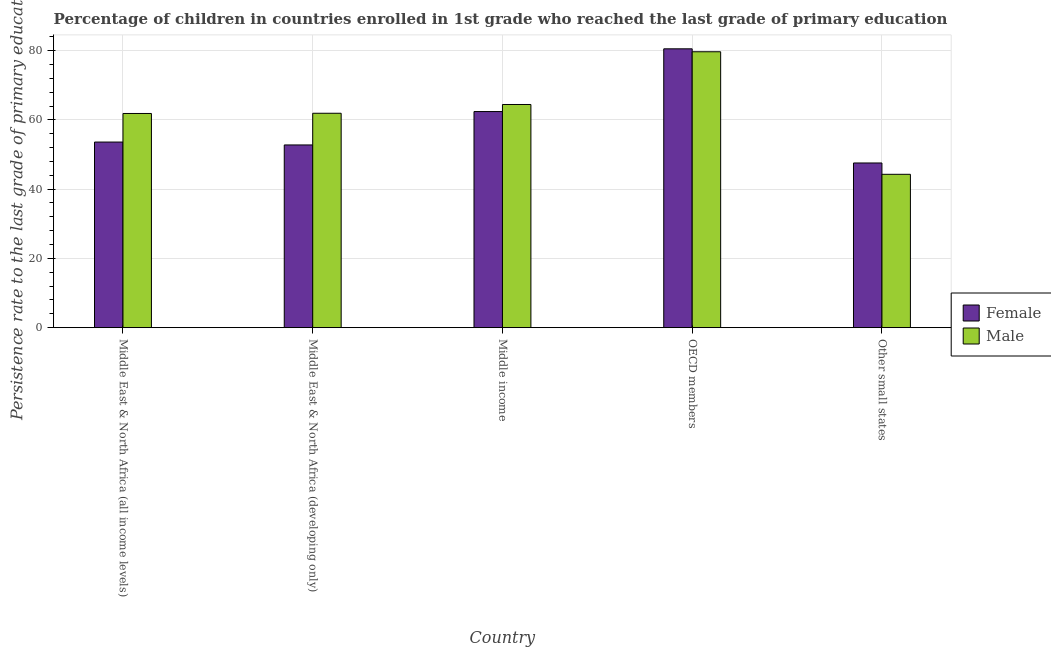How many different coloured bars are there?
Provide a succinct answer. 2. Are the number of bars per tick equal to the number of legend labels?
Ensure brevity in your answer.  Yes. How many bars are there on the 3rd tick from the left?
Ensure brevity in your answer.  2. What is the label of the 2nd group of bars from the left?
Ensure brevity in your answer.  Middle East & North Africa (developing only). What is the persistence rate of male students in OECD members?
Keep it short and to the point. 79.66. Across all countries, what is the maximum persistence rate of male students?
Your response must be concise. 79.66. Across all countries, what is the minimum persistence rate of female students?
Your response must be concise. 47.55. In which country was the persistence rate of male students maximum?
Your answer should be very brief. OECD members. In which country was the persistence rate of male students minimum?
Provide a succinct answer. Other small states. What is the total persistence rate of female students in the graph?
Offer a terse response. 296.81. What is the difference between the persistence rate of male students in Middle East & North Africa (all income levels) and that in OECD members?
Ensure brevity in your answer.  -17.82. What is the difference between the persistence rate of female students in Middle East & North Africa (developing only) and the persistence rate of male students in Other small states?
Provide a succinct answer. 8.48. What is the average persistence rate of male students per country?
Offer a very short reply. 62.43. What is the difference between the persistence rate of male students and persistence rate of female students in Middle income?
Provide a short and direct response. 2.04. What is the ratio of the persistence rate of male students in Middle East & North Africa (developing only) to that in OECD members?
Make the answer very short. 0.78. What is the difference between the highest and the second highest persistence rate of female students?
Offer a terse response. 18.11. What is the difference between the highest and the lowest persistence rate of female students?
Provide a succinct answer. 32.96. In how many countries, is the persistence rate of male students greater than the average persistence rate of male students taken over all countries?
Offer a very short reply. 2. Is the sum of the persistence rate of male students in Middle East & North Africa (developing only) and Middle income greater than the maximum persistence rate of female students across all countries?
Your answer should be very brief. Yes. What does the 2nd bar from the left in Other small states represents?
Provide a short and direct response. Male. What does the 2nd bar from the right in Middle East & North Africa (developing only) represents?
Keep it short and to the point. Female. Are all the bars in the graph horizontal?
Offer a very short reply. No. How many countries are there in the graph?
Ensure brevity in your answer.  5. Does the graph contain grids?
Give a very brief answer. Yes. Where does the legend appear in the graph?
Offer a very short reply. Center right. How many legend labels are there?
Your response must be concise. 2. What is the title of the graph?
Give a very brief answer. Percentage of children in countries enrolled in 1st grade who reached the last grade of primary education. What is the label or title of the Y-axis?
Offer a very short reply. Persistence rate to the last grade of primary education (%). What is the Persistence rate to the last grade of primary education (%) of Female in Middle East & North Africa (all income levels)?
Make the answer very short. 53.59. What is the Persistence rate to the last grade of primary education (%) of Male in Middle East & North Africa (all income levels)?
Make the answer very short. 61.84. What is the Persistence rate to the last grade of primary education (%) of Female in Middle East & North Africa (developing only)?
Make the answer very short. 52.76. What is the Persistence rate to the last grade of primary education (%) in Male in Middle East & North Africa (developing only)?
Offer a very short reply. 61.91. What is the Persistence rate to the last grade of primary education (%) in Female in Middle income?
Keep it short and to the point. 62.4. What is the Persistence rate to the last grade of primary education (%) of Male in Middle income?
Offer a very short reply. 64.44. What is the Persistence rate to the last grade of primary education (%) in Female in OECD members?
Ensure brevity in your answer.  80.51. What is the Persistence rate to the last grade of primary education (%) in Male in OECD members?
Offer a terse response. 79.66. What is the Persistence rate to the last grade of primary education (%) of Female in Other small states?
Provide a succinct answer. 47.55. What is the Persistence rate to the last grade of primary education (%) of Male in Other small states?
Offer a terse response. 44.28. Across all countries, what is the maximum Persistence rate to the last grade of primary education (%) in Female?
Your response must be concise. 80.51. Across all countries, what is the maximum Persistence rate to the last grade of primary education (%) of Male?
Give a very brief answer. 79.66. Across all countries, what is the minimum Persistence rate to the last grade of primary education (%) in Female?
Make the answer very short. 47.55. Across all countries, what is the minimum Persistence rate to the last grade of primary education (%) in Male?
Offer a very short reply. 44.28. What is the total Persistence rate to the last grade of primary education (%) in Female in the graph?
Your answer should be compact. 296.81. What is the total Persistence rate to the last grade of primary education (%) in Male in the graph?
Your answer should be very brief. 312.13. What is the difference between the Persistence rate to the last grade of primary education (%) in Female in Middle East & North Africa (all income levels) and that in Middle East & North Africa (developing only)?
Your response must be concise. 0.84. What is the difference between the Persistence rate to the last grade of primary education (%) of Male in Middle East & North Africa (all income levels) and that in Middle East & North Africa (developing only)?
Ensure brevity in your answer.  -0.06. What is the difference between the Persistence rate to the last grade of primary education (%) of Female in Middle East & North Africa (all income levels) and that in Middle income?
Your answer should be compact. -8.8. What is the difference between the Persistence rate to the last grade of primary education (%) in Male in Middle East & North Africa (all income levels) and that in Middle income?
Provide a short and direct response. -2.59. What is the difference between the Persistence rate to the last grade of primary education (%) of Female in Middle East & North Africa (all income levels) and that in OECD members?
Offer a terse response. -26.92. What is the difference between the Persistence rate to the last grade of primary education (%) of Male in Middle East & North Africa (all income levels) and that in OECD members?
Offer a very short reply. -17.82. What is the difference between the Persistence rate to the last grade of primary education (%) in Female in Middle East & North Africa (all income levels) and that in Other small states?
Offer a terse response. 6.04. What is the difference between the Persistence rate to the last grade of primary education (%) of Male in Middle East & North Africa (all income levels) and that in Other small states?
Offer a very short reply. 17.56. What is the difference between the Persistence rate to the last grade of primary education (%) of Female in Middle East & North Africa (developing only) and that in Middle income?
Ensure brevity in your answer.  -9.64. What is the difference between the Persistence rate to the last grade of primary education (%) in Male in Middle East & North Africa (developing only) and that in Middle income?
Offer a very short reply. -2.53. What is the difference between the Persistence rate to the last grade of primary education (%) of Female in Middle East & North Africa (developing only) and that in OECD members?
Your answer should be compact. -27.76. What is the difference between the Persistence rate to the last grade of primary education (%) of Male in Middle East & North Africa (developing only) and that in OECD members?
Your answer should be very brief. -17.76. What is the difference between the Persistence rate to the last grade of primary education (%) in Female in Middle East & North Africa (developing only) and that in Other small states?
Your answer should be very brief. 5.2. What is the difference between the Persistence rate to the last grade of primary education (%) of Male in Middle East & North Africa (developing only) and that in Other small states?
Give a very brief answer. 17.63. What is the difference between the Persistence rate to the last grade of primary education (%) in Female in Middle income and that in OECD members?
Keep it short and to the point. -18.11. What is the difference between the Persistence rate to the last grade of primary education (%) in Male in Middle income and that in OECD members?
Offer a terse response. -15.23. What is the difference between the Persistence rate to the last grade of primary education (%) of Female in Middle income and that in Other small states?
Provide a short and direct response. 14.85. What is the difference between the Persistence rate to the last grade of primary education (%) of Male in Middle income and that in Other small states?
Offer a very short reply. 20.16. What is the difference between the Persistence rate to the last grade of primary education (%) of Female in OECD members and that in Other small states?
Your answer should be compact. 32.96. What is the difference between the Persistence rate to the last grade of primary education (%) in Male in OECD members and that in Other small states?
Provide a short and direct response. 35.38. What is the difference between the Persistence rate to the last grade of primary education (%) of Female in Middle East & North Africa (all income levels) and the Persistence rate to the last grade of primary education (%) of Male in Middle East & North Africa (developing only)?
Give a very brief answer. -8.31. What is the difference between the Persistence rate to the last grade of primary education (%) in Female in Middle East & North Africa (all income levels) and the Persistence rate to the last grade of primary education (%) in Male in Middle income?
Your response must be concise. -10.84. What is the difference between the Persistence rate to the last grade of primary education (%) in Female in Middle East & North Africa (all income levels) and the Persistence rate to the last grade of primary education (%) in Male in OECD members?
Provide a short and direct response. -26.07. What is the difference between the Persistence rate to the last grade of primary education (%) in Female in Middle East & North Africa (all income levels) and the Persistence rate to the last grade of primary education (%) in Male in Other small states?
Your response must be concise. 9.31. What is the difference between the Persistence rate to the last grade of primary education (%) in Female in Middle East & North Africa (developing only) and the Persistence rate to the last grade of primary education (%) in Male in Middle income?
Give a very brief answer. -11.68. What is the difference between the Persistence rate to the last grade of primary education (%) of Female in Middle East & North Africa (developing only) and the Persistence rate to the last grade of primary education (%) of Male in OECD members?
Provide a short and direct response. -26.91. What is the difference between the Persistence rate to the last grade of primary education (%) of Female in Middle East & North Africa (developing only) and the Persistence rate to the last grade of primary education (%) of Male in Other small states?
Your answer should be very brief. 8.48. What is the difference between the Persistence rate to the last grade of primary education (%) in Female in Middle income and the Persistence rate to the last grade of primary education (%) in Male in OECD members?
Make the answer very short. -17.27. What is the difference between the Persistence rate to the last grade of primary education (%) in Female in Middle income and the Persistence rate to the last grade of primary education (%) in Male in Other small states?
Your answer should be compact. 18.12. What is the difference between the Persistence rate to the last grade of primary education (%) in Female in OECD members and the Persistence rate to the last grade of primary education (%) in Male in Other small states?
Make the answer very short. 36.23. What is the average Persistence rate to the last grade of primary education (%) in Female per country?
Ensure brevity in your answer.  59.36. What is the average Persistence rate to the last grade of primary education (%) in Male per country?
Provide a succinct answer. 62.43. What is the difference between the Persistence rate to the last grade of primary education (%) in Female and Persistence rate to the last grade of primary education (%) in Male in Middle East & North Africa (all income levels)?
Make the answer very short. -8.25. What is the difference between the Persistence rate to the last grade of primary education (%) of Female and Persistence rate to the last grade of primary education (%) of Male in Middle East & North Africa (developing only)?
Provide a succinct answer. -9.15. What is the difference between the Persistence rate to the last grade of primary education (%) of Female and Persistence rate to the last grade of primary education (%) of Male in Middle income?
Offer a terse response. -2.04. What is the difference between the Persistence rate to the last grade of primary education (%) of Female and Persistence rate to the last grade of primary education (%) of Male in OECD members?
Provide a succinct answer. 0.85. What is the difference between the Persistence rate to the last grade of primary education (%) of Female and Persistence rate to the last grade of primary education (%) of Male in Other small states?
Ensure brevity in your answer.  3.27. What is the ratio of the Persistence rate to the last grade of primary education (%) in Female in Middle East & North Africa (all income levels) to that in Middle East & North Africa (developing only)?
Make the answer very short. 1.02. What is the ratio of the Persistence rate to the last grade of primary education (%) of Male in Middle East & North Africa (all income levels) to that in Middle East & North Africa (developing only)?
Give a very brief answer. 1. What is the ratio of the Persistence rate to the last grade of primary education (%) of Female in Middle East & North Africa (all income levels) to that in Middle income?
Ensure brevity in your answer.  0.86. What is the ratio of the Persistence rate to the last grade of primary education (%) of Male in Middle East & North Africa (all income levels) to that in Middle income?
Make the answer very short. 0.96. What is the ratio of the Persistence rate to the last grade of primary education (%) in Female in Middle East & North Africa (all income levels) to that in OECD members?
Give a very brief answer. 0.67. What is the ratio of the Persistence rate to the last grade of primary education (%) of Male in Middle East & North Africa (all income levels) to that in OECD members?
Offer a very short reply. 0.78. What is the ratio of the Persistence rate to the last grade of primary education (%) of Female in Middle East & North Africa (all income levels) to that in Other small states?
Give a very brief answer. 1.13. What is the ratio of the Persistence rate to the last grade of primary education (%) of Male in Middle East & North Africa (all income levels) to that in Other small states?
Keep it short and to the point. 1.4. What is the ratio of the Persistence rate to the last grade of primary education (%) of Female in Middle East & North Africa (developing only) to that in Middle income?
Provide a succinct answer. 0.85. What is the ratio of the Persistence rate to the last grade of primary education (%) of Male in Middle East & North Africa (developing only) to that in Middle income?
Make the answer very short. 0.96. What is the ratio of the Persistence rate to the last grade of primary education (%) in Female in Middle East & North Africa (developing only) to that in OECD members?
Offer a very short reply. 0.66. What is the ratio of the Persistence rate to the last grade of primary education (%) in Male in Middle East & North Africa (developing only) to that in OECD members?
Your response must be concise. 0.78. What is the ratio of the Persistence rate to the last grade of primary education (%) in Female in Middle East & North Africa (developing only) to that in Other small states?
Make the answer very short. 1.11. What is the ratio of the Persistence rate to the last grade of primary education (%) of Male in Middle East & North Africa (developing only) to that in Other small states?
Provide a succinct answer. 1.4. What is the ratio of the Persistence rate to the last grade of primary education (%) in Female in Middle income to that in OECD members?
Your answer should be compact. 0.78. What is the ratio of the Persistence rate to the last grade of primary education (%) in Male in Middle income to that in OECD members?
Give a very brief answer. 0.81. What is the ratio of the Persistence rate to the last grade of primary education (%) in Female in Middle income to that in Other small states?
Your response must be concise. 1.31. What is the ratio of the Persistence rate to the last grade of primary education (%) in Male in Middle income to that in Other small states?
Give a very brief answer. 1.46. What is the ratio of the Persistence rate to the last grade of primary education (%) in Female in OECD members to that in Other small states?
Provide a succinct answer. 1.69. What is the ratio of the Persistence rate to the last grade of primary education (%) of Male in OECD members to that in Other small states?
Offer a very short reply. 1.8. What is the difference between the highest and the second highest Persistence rate to the last grade of primary education (%) in Female?
Offer a very short reply. 18.11. What is the difference between the highest and the second highest Persistence rate to the last grade of primary education (%) of Male?
Make the answer very short. 15.23. What is the difference between the highest and the lowest Persistence rate to the last grade of primary education (%) of Female?
Keep it short and to the point. 32.96. What is the difference between the highest and the lowest Persistence rate to the last grade of primary education (%) of Male?
Make the answer very short. 35.38. 